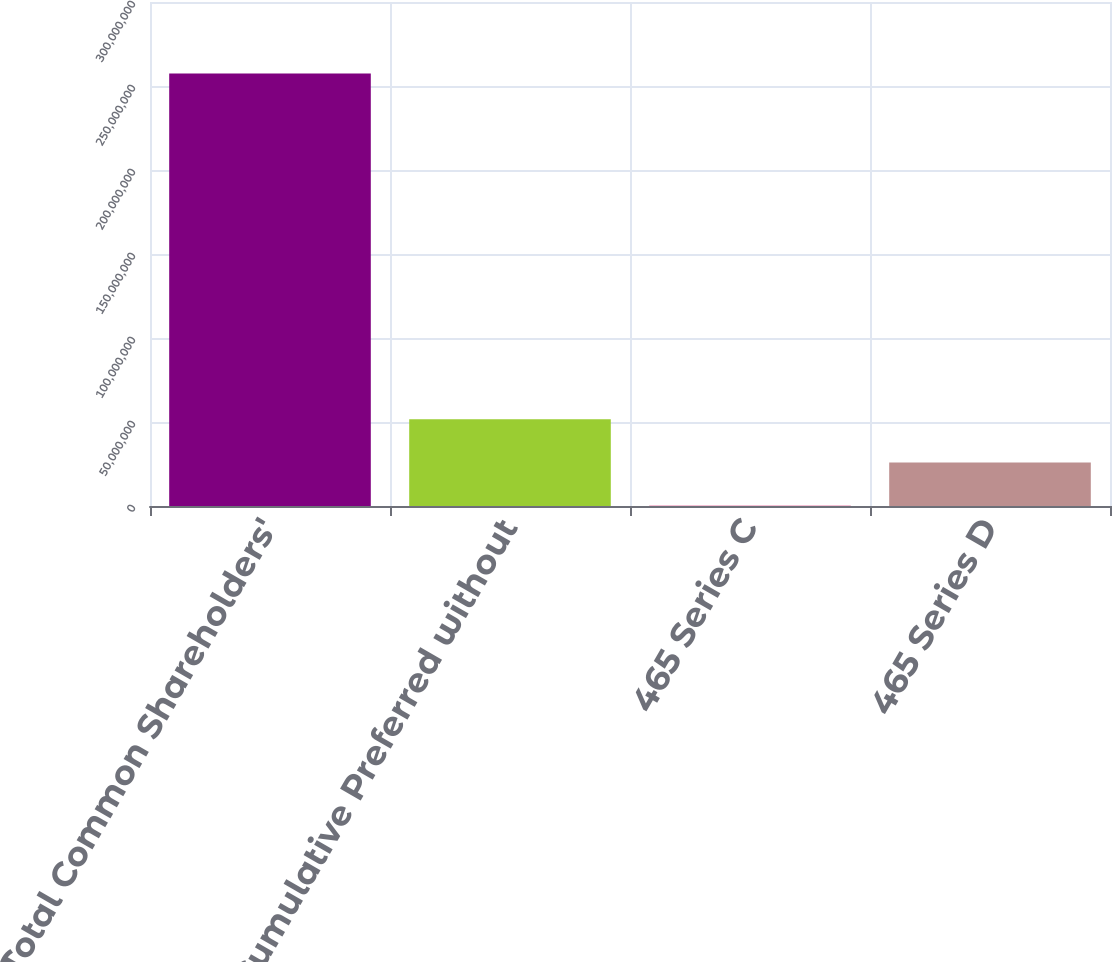<chart> <loc_0><loc_0><loc_500><loc_500><bar_chart><fcel>Total Common Shareholders'<fcel>5 Cumulative Preferred without<fcel>465 Series C<fcel>465 Series D<nl><fcel>2.57456e+08<fcel>5.16139e+07<fcel>153296<fcel>2.58836e+07<nl></chart> 